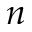Convert formula to latex. <formula><loc_0><loc_0><loc_500><loc_500>n</formula> 